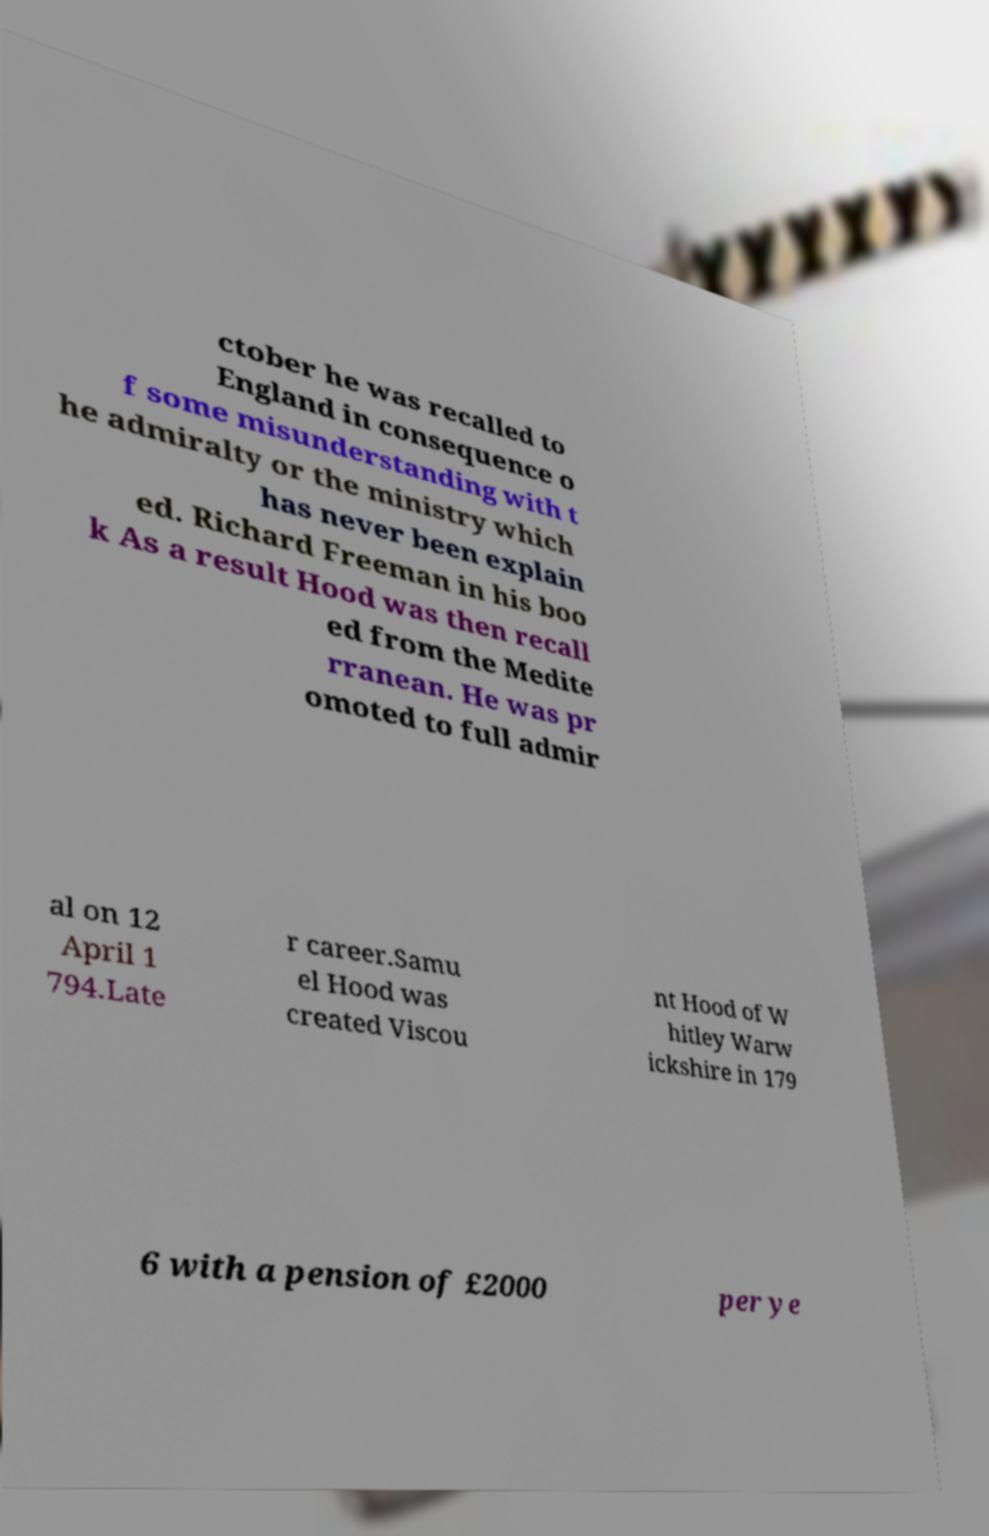Can you accurately transcribe the text from the provided image for me? ctober he was recalled to England in consequence o f some misunderstanding with t he admiralty or the ministry which has never been explain ed. Richard Freeman in his boo k As a result Hood was then recall ed from the Medite rranean. He was pr omoted to full admir al on 12 April 1 794.Late r career.Samu el Hood was created Viscou nt Hood of W hitley Warw ickshire in 179 6 with a pension of £2000 per ye 